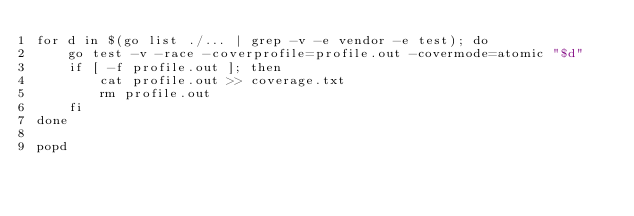Convert code to text. <code><loc_0><loc_0><loc_500><loc_500><_Bash_>for d in $(go list ./... | grep -v -e vendor -e test); do
    go test -v -race -coverprofile=profile.out -covermode=atomic "$d"
    if [ -f profile.out ]; then
        cat profile.out >> coverage.txt
        rm profile.out
    fi
done

popd
</code> 